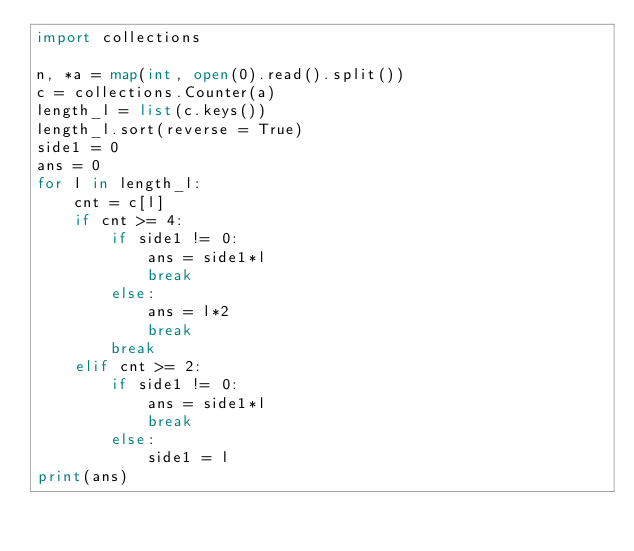Convert code to text. <code><loc_0><loc_0><loc_500><loc_500><_Python_>import collections

n, *a = map(int, open(0).read().split())
c = collections.Counter(a)
length_l = list(c.keys())
length_l.sort(reverse = True)
side1 = 0
ans = 0
for l in length_l:
    cnt = c[l]
    if cnt >= 4:
        if side1 != 0:
            ans = side1*l
            break
        else:
            ans = l*2
            break
        break
    elif cnt >= 2:
        if side1 != 0:
            ans = side1*l
            break
        else:
            side1 = l
print(ans)</code> 